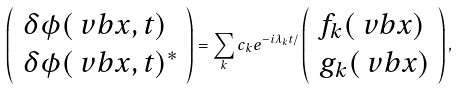Convert formula to latex. <formula><loc_0><loc_0><loc_500><loc_500>\left ( \begin{array} { l } \delta \phi ( \ v b { x } , t ) \\ \delta \phi ( \ v b { x } , t ) ^ { * } \end{array} \right ) = \sum _ { k } c _ { k } e ^ { - i \lambda _ { k } t / } \left ( \begin{array} { l } f _ { k } ( \ v b { x } ) \\ g _ { k } ( \ v b { x } ) \end{array} \right ) ,</formula> 